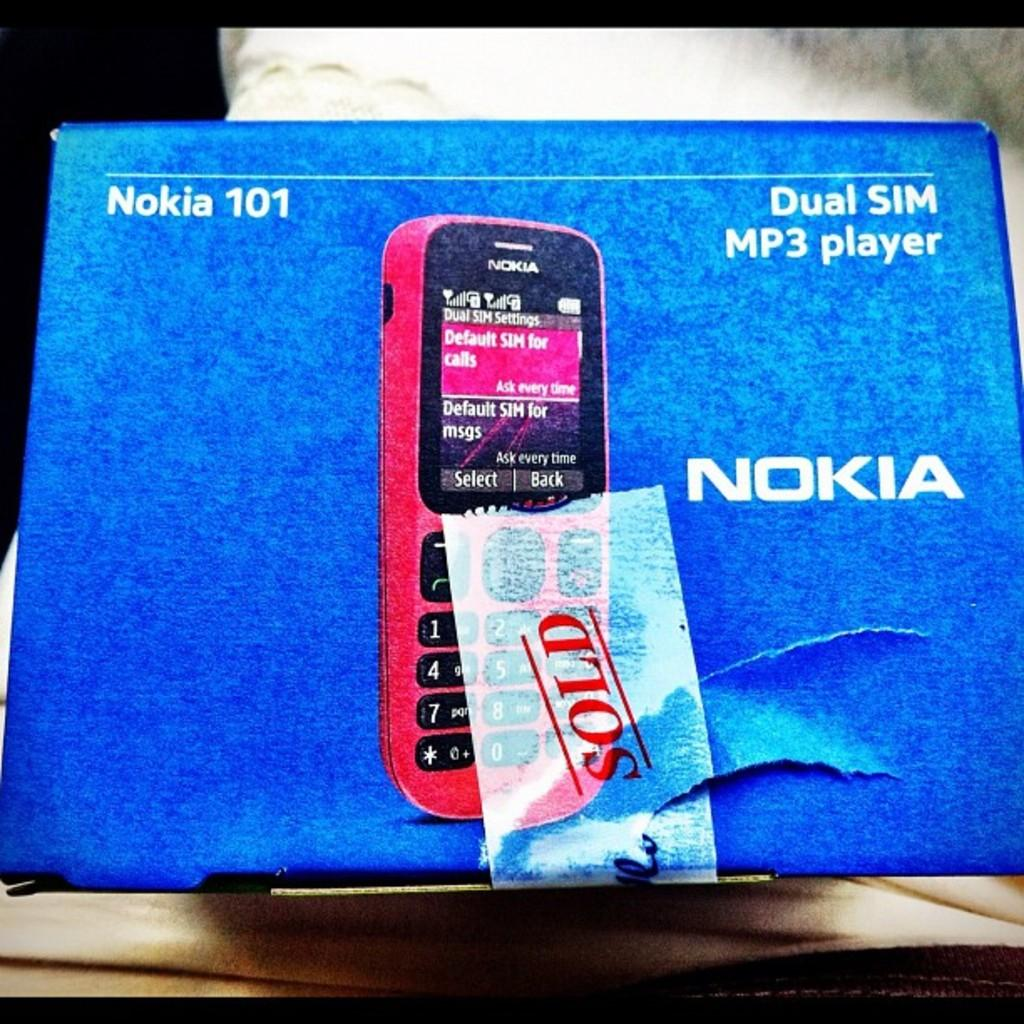Provide a one-sentence caption for the provided image. a phone that has a Nokia on it. 